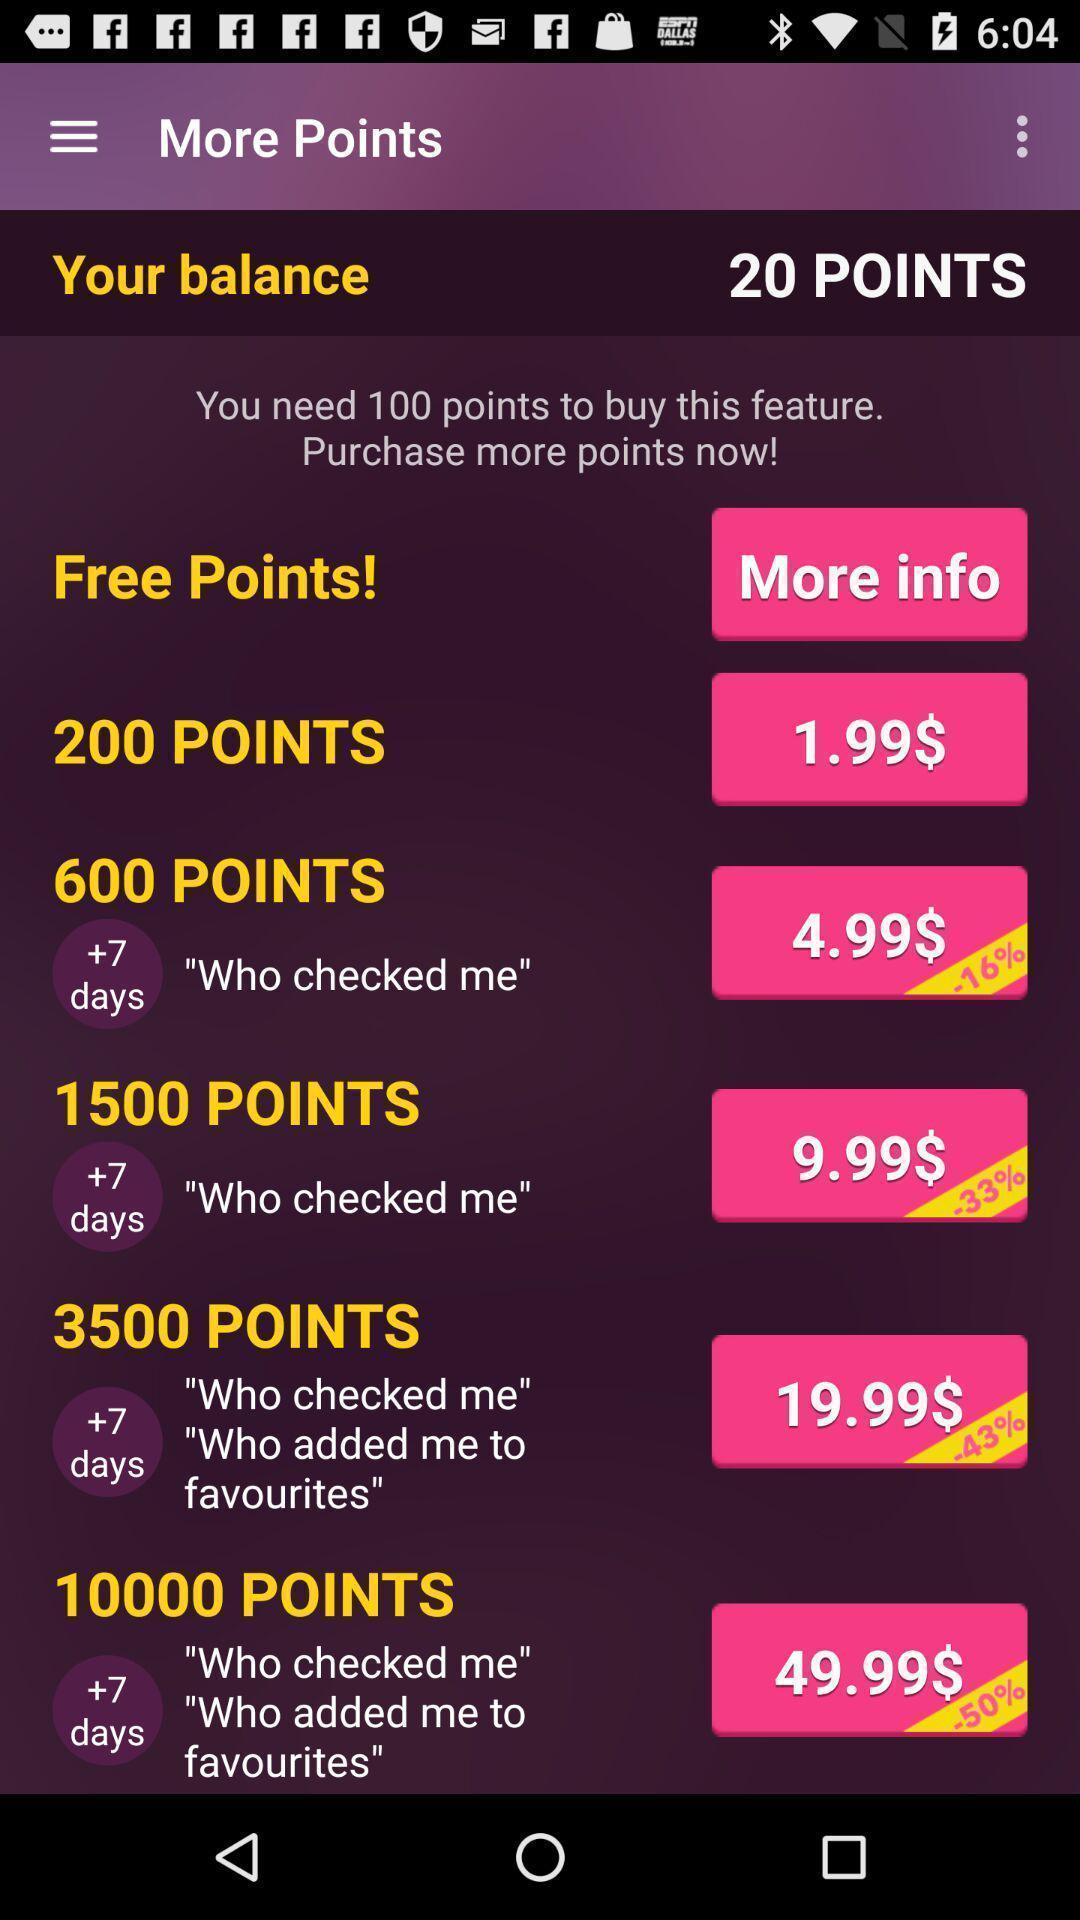Please provide a description for this image. Screen showing more points. 